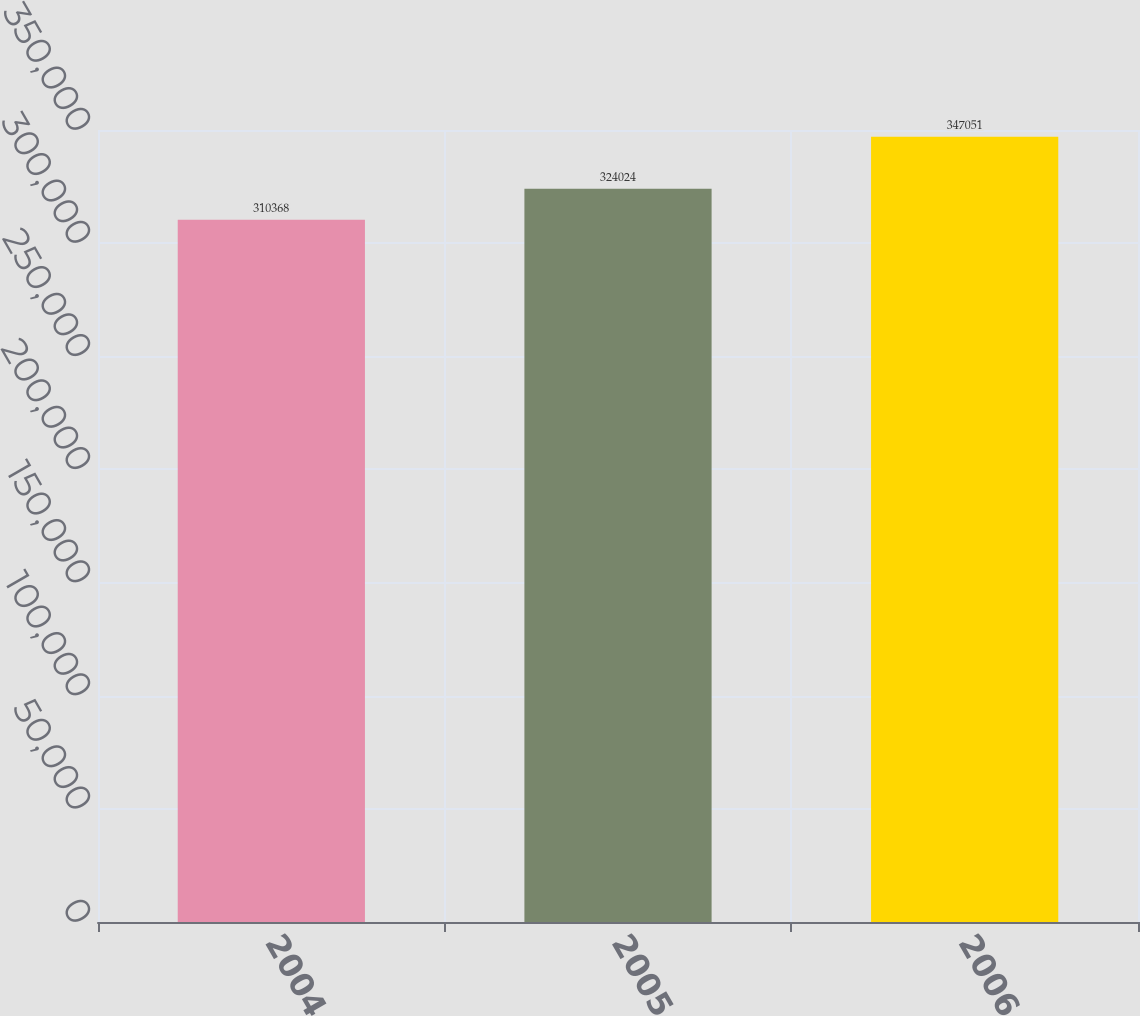Convert chart. <chart><loc_0><loc_0><loc_500><loc_500><bar_chart><fcel>2004<fcel>2005<fcel>2006<nl><fcel>310368<fcel>324024<fcel>347051<nl></chart> 